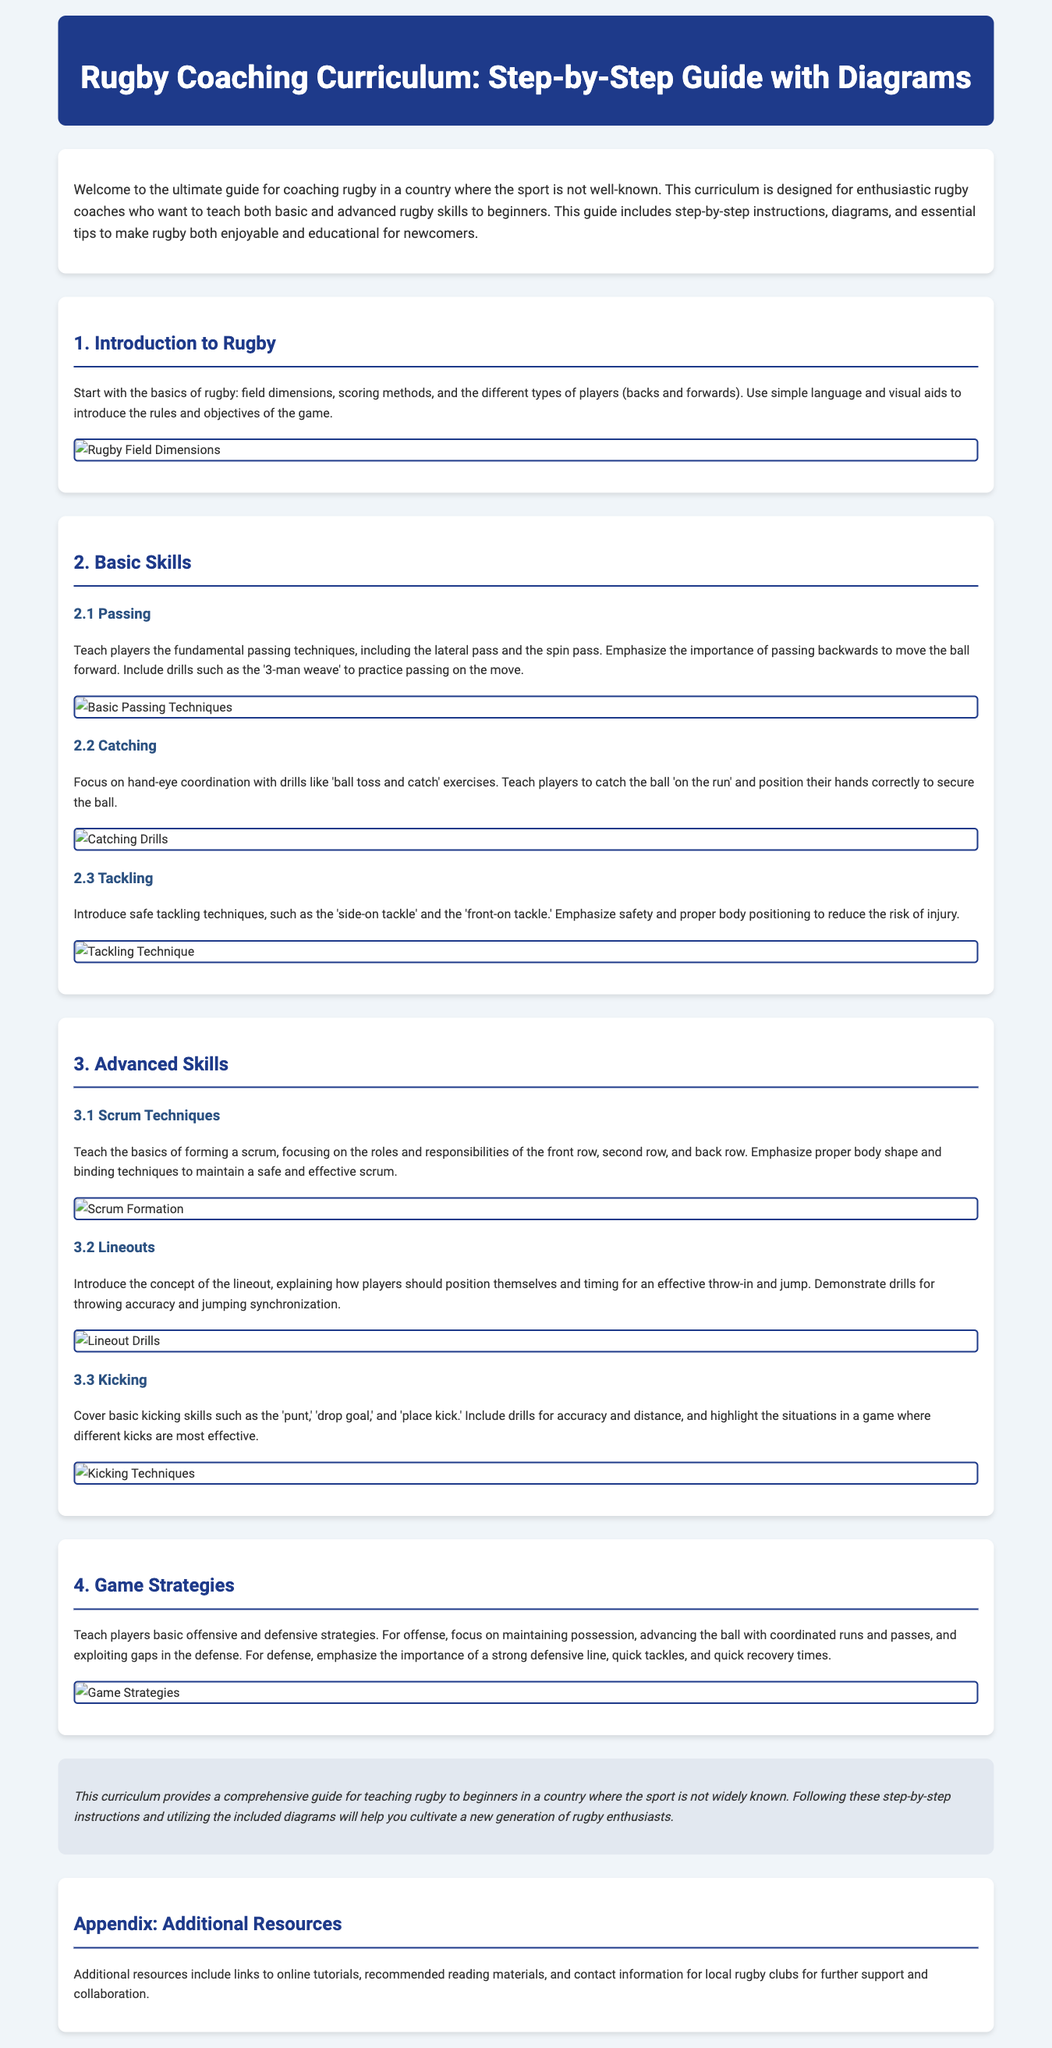What is the title of the document? The title is mentioned at the top of the document, indicating the main subject of the content.
Answer: Rugby Coaching Curriculum: Step-by-Step Guide with Diagrams How many main sections are in the curriculum? The main sections are numbered, indicating their count in the document.
Answer: Four What skill is taught in section 2.1? The section has a specific focus on fundamental techniques related to a core skill in rugby.
Answer: Passing What type of tackle is introduced in section 2.3? The document specifies safe tackling techniques as part of the curriculum.
Answer: Side-on tackle What strategies are highlighted in section 4 of the document? The section discusses specific approaches related to the performance during gameplay.
Answer: Offensive and defensive strategies What is the purpose of the appendix? The appendix is included to provide further assistance and resources to the readers.
Answer: Additional resources What visual aids are mentioned in the curriculum? The document refers to various illustrations that complement the explanations throughout the sections.
Answer: Diagrams What is emphasized for kicking techniques in section 3.3? The section covers important aspects related to a particular skill involving the use of feet.
Answer: Accuracy and distance What is the audience for this rugby curriculum? The introductory paragraph describes who can benefit from the curriculum presented in the document.
Answer: Enthusiastic rugby coaches 